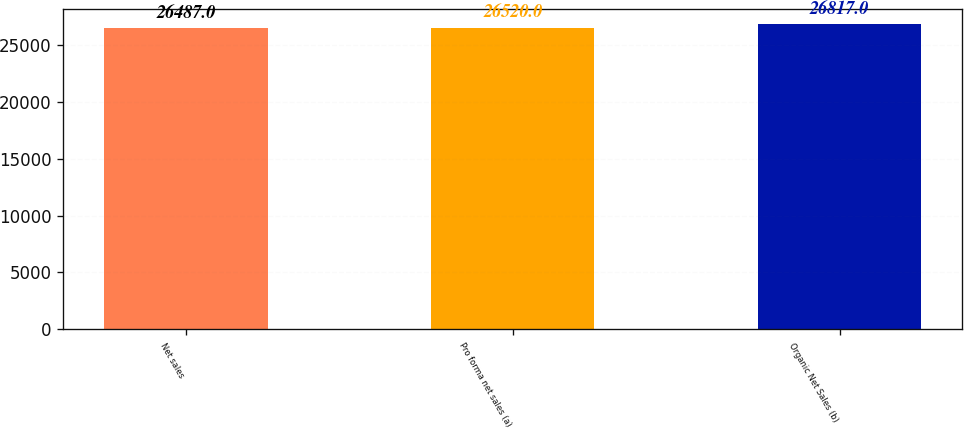<chart> <loc_0><loc_0><loc_500><loc_500><bar_chart><fcel>Net sales<fcel>Pro forma net sales (a)<fcel>Organic Net Sales (b)<nl><fcel>26487<fcel>26520<fcel>26817<nl></chart> 